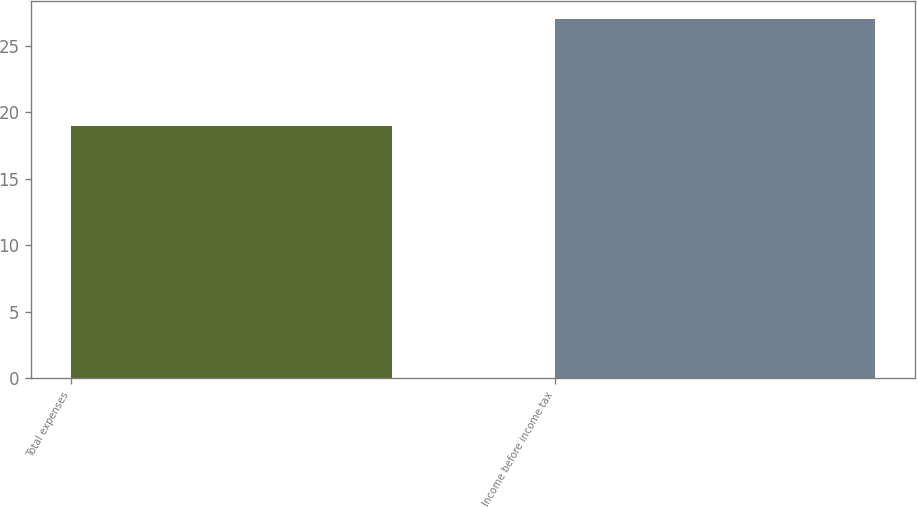Convert chart to OTSL. <chart><loc_0><loc_0><loc_500><loc_500><bar_chart><fcel>Total expenses<fcel>Income before income tax<nl><fcel>19<fcel>27<nl></chart> 